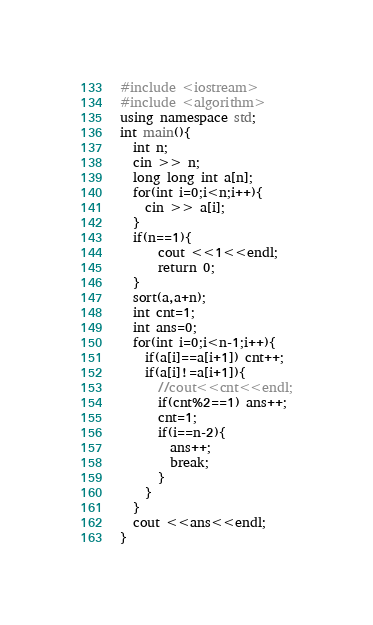<code> <loc_0><loc_0><loc_500><loc_500><_C++_>#include <iostream>
#include <algorithm>
using namespace std;
int main(){
  int n;
  cin >> n;
  long long int a[n];
  for(int i=0;i<n;i++){
    cin >> a[i];
  }
  if(n==1){
      cout <<1<<endl;
      return 0;
  }
  sort(a,a+n);
  int cnt=1;
  int ans=0;
  for(int i=0;i<n-1;i++){
    if(a[i]==a[i+1]) cnt++;
    if(a[i]!=a[i+1]){
      //cout<<cnt<<endl;
      if(cnt%2==1) ans++;
      cnt=1;
      if(i==n-2){
        ans++;
        break;
      }
    }
  }
  cout <<ans<<endl;
}
</code> 